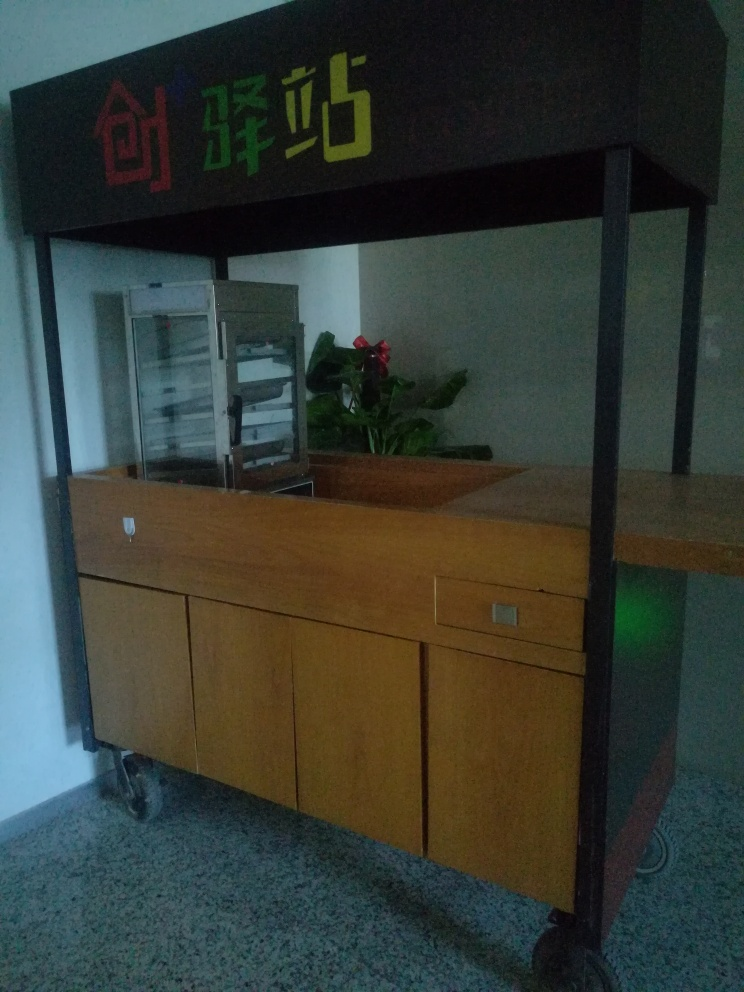What does the signage above the furniture indicate about its location or use? The signage features what appears to be Asian characters, suggesting that the furniture is located in a region where such writing is prevalent, possibly as a nameplate or indicator of an area within a larger facility, perhaps a library or archive section. Is there anything unique or distinguishing about the signage's design? The colorful characters contrasted against the dark background make the signage visually appealing and attention-grabbing. Its distinctive style could imply a cultural or branding aspect, adding an identity to the space it represents. 